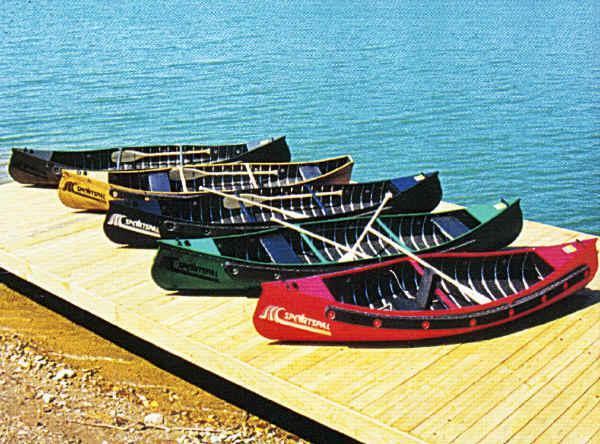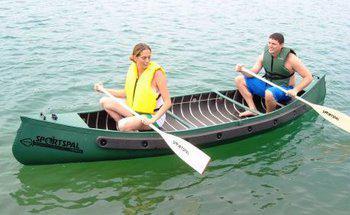The first image is the image on the left, the second image is the image on the right. For the images shown, is this caption "the image on the righ contains humans" true? Answer yes or no. Yes. 